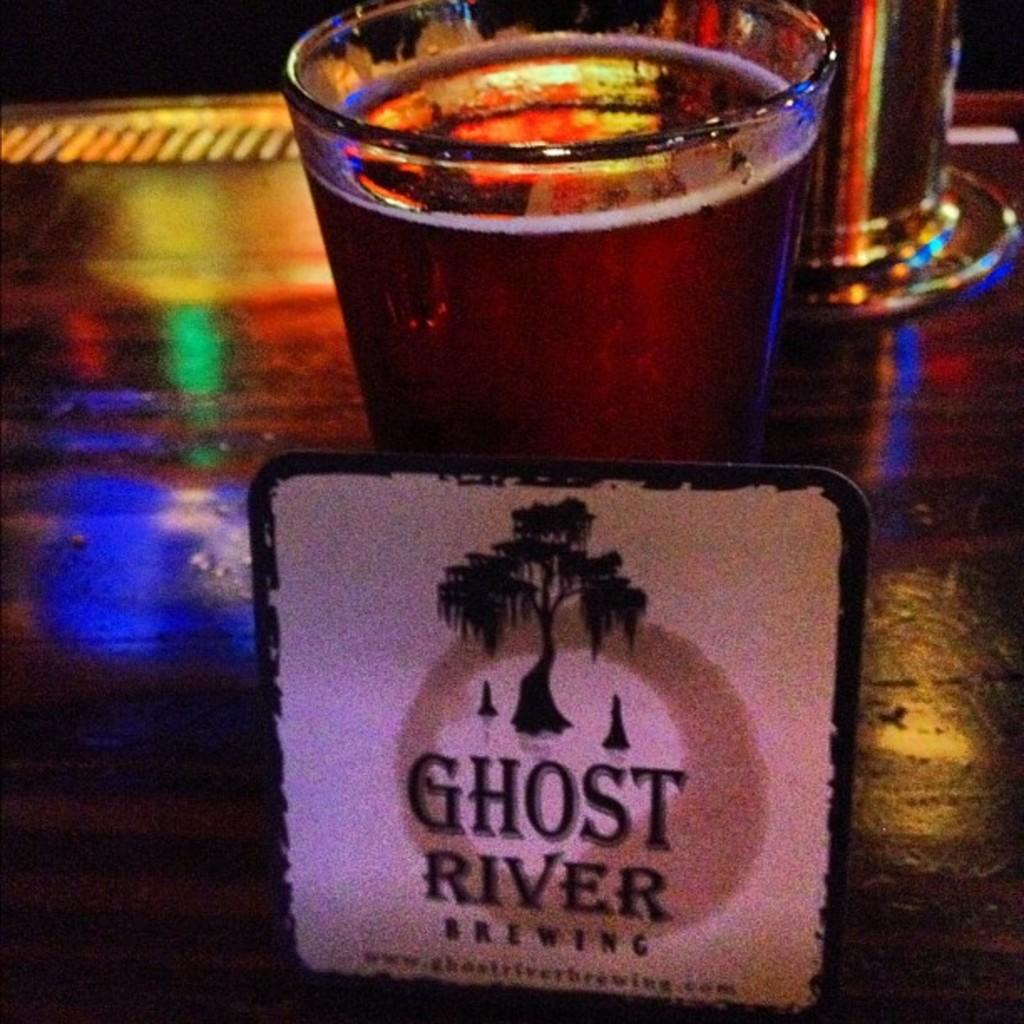<image>
Render a clear and concise summary of the photo. A Ghost River Brewing coaster leaning on a tall glass of beer. 